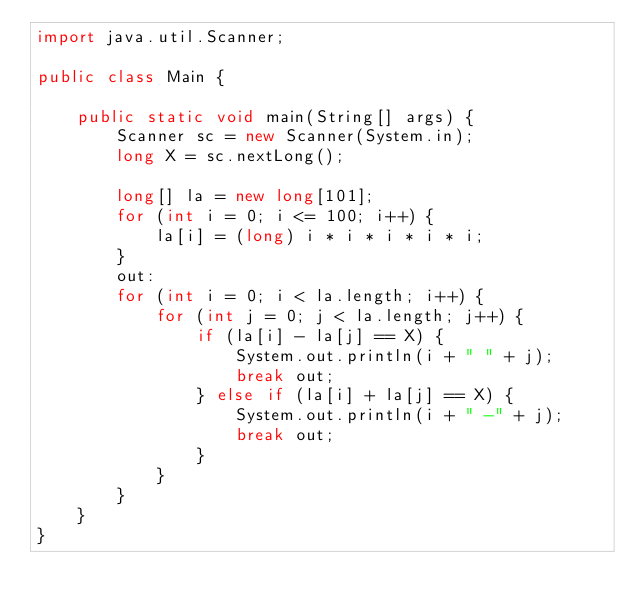Convert code to text. <code><loc_0><loc_0><loc_500><loc_500><_Java_>import java.util.Scanner;

public class Main {

    public static void main(String[] args) {
        Scanner sc = new Scanner(System.in);
        long X = sc.nextLong();

        long[] la = new long[101];
        for (int i = 0; i <= 100; i++) {
            la[i] = (long) i * i * i * i * i;
        }
        out:
        for (int i = 0; i < la.length; i++) {
            for (int j = 0; j < la.length; j++) {
                if (la[i] - la[j] == X) {
                    System.out.println(i + " " + j);
                    break out;
                } else if (la[i] + la[j] == X) {
                    System.out.println(i + " -" + j);
                    break out;
                }
            }
        }
    }
}</code> 